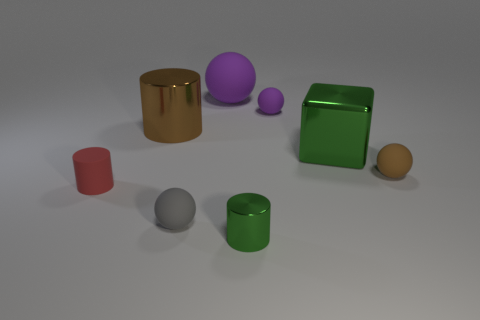Is the color of the shiny cylinder behind the tiny red matte object the same as the big matte thing?
Your response must be concise. No. What number of other big rubber things have the same shape as the large brown object?
Give a very brief answer. 0. Is the number of small brown balls that are in front of the small brown ball the same as the number of big blue metal things?
Your answer should be very brief. Yes. What color is the ball that is the same size as the green block?
Provide a short and direct response. Purple. Are there any yellow matte things of the same shape as the brown matte object?
Your response must be concise. No. What is the material of the cylinder on the left side of the big cylinder right of the small cylinder to the left of the small green metal cylinder?
Make the answer very short. Rubber. How many other things are the same size as the red rubber thing?
Keep it short and to the point. 4. The tiny shiny object is what color?
Keep it short and to the point. Green. What number of metal objects are yellow spheres or green cylinders?
Provide a short and direct response. 1. Is there anything else that is the same material as the red cylinder?
Provide a short and direct response. Yes. 